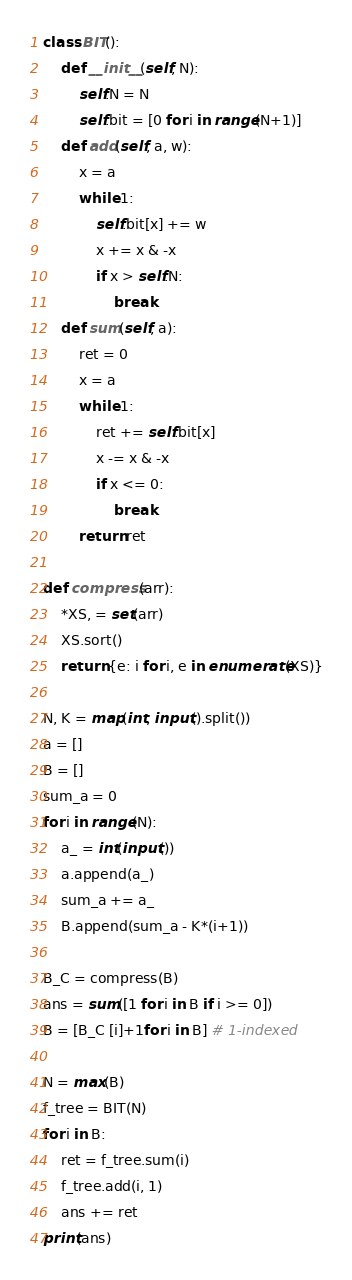Convert code to text. <code><loc_0><loc_0><loc_500><loc_500><_Python_>class BIT():
    def __init__(self, N):
        self.N = N
        self.bit = [0 for i in range(N+1)]
    def add(self, a, w):
        x = a
        while 1:
            self.bit[x] += w
            x += x & -x
            if x > self.N:
                break
    def sum(self, a):
        ret = 0
        x = a
        while 1:
            ret += self.bit[x]
            x -= x & -x
            if x <= 0:
                break
        return ret
    
def compress(arr):
    *XS, = set(arr)
    XS.sort()
    return {e: i for i, e in enumerate(XS)}

N, K = map(int, input().split())
a = []
B = []
sum_a = 0
for i in range(N):
    a_ = int(input())
    a.append(a_)
    sum_a += a_
    B.append(sum_a - K*(i+1))

B_C = compress(B)
ans = sum([1 for i in B if i >= 0])
B = [B_C [i]+1for i in B] # 1-indexed

N = max(B)
f_tree = BIT(N)
for i in B:
    ret = f_tree.sum(i)
    f_tree.add(i, 1)
    ans += ret
print(ans)</code> 